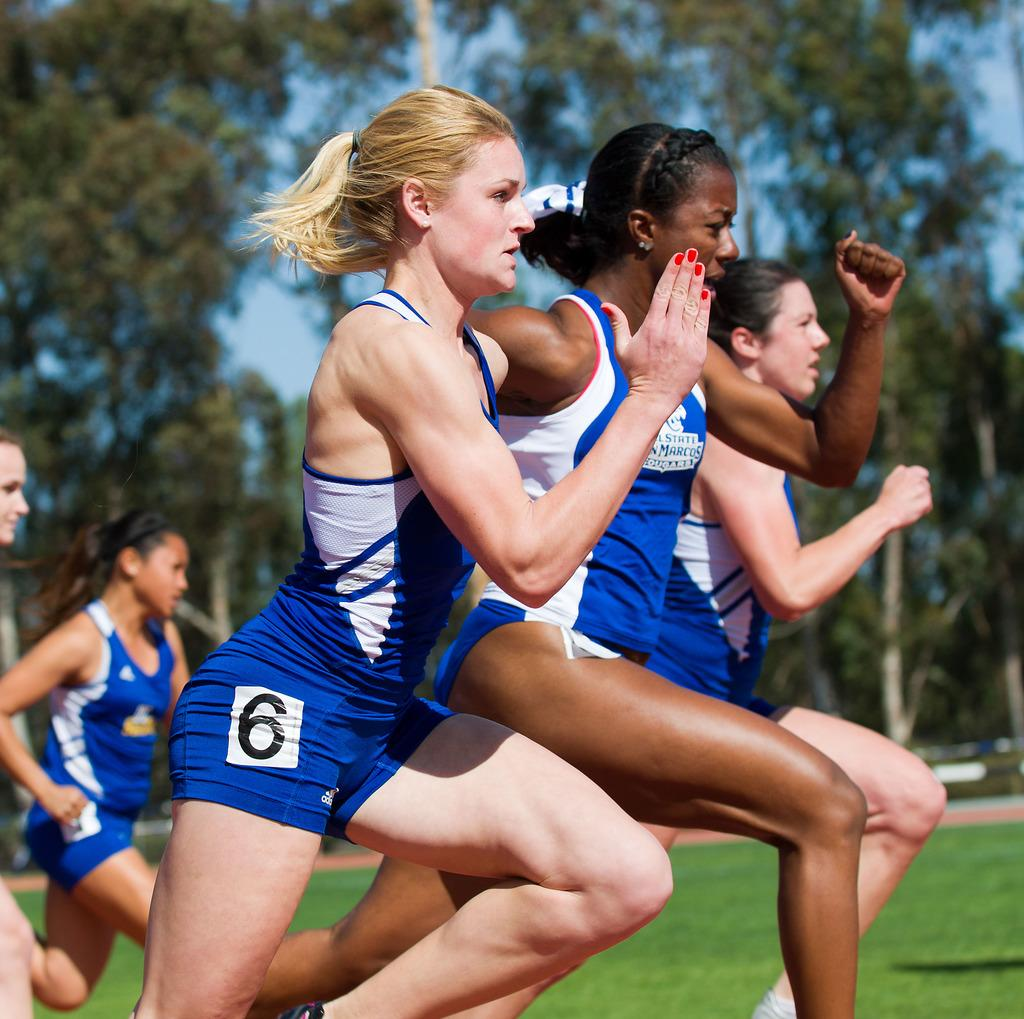<image>
Create a compact narrative representing the image presented. The girls are focused and running fast, especially number 6. 